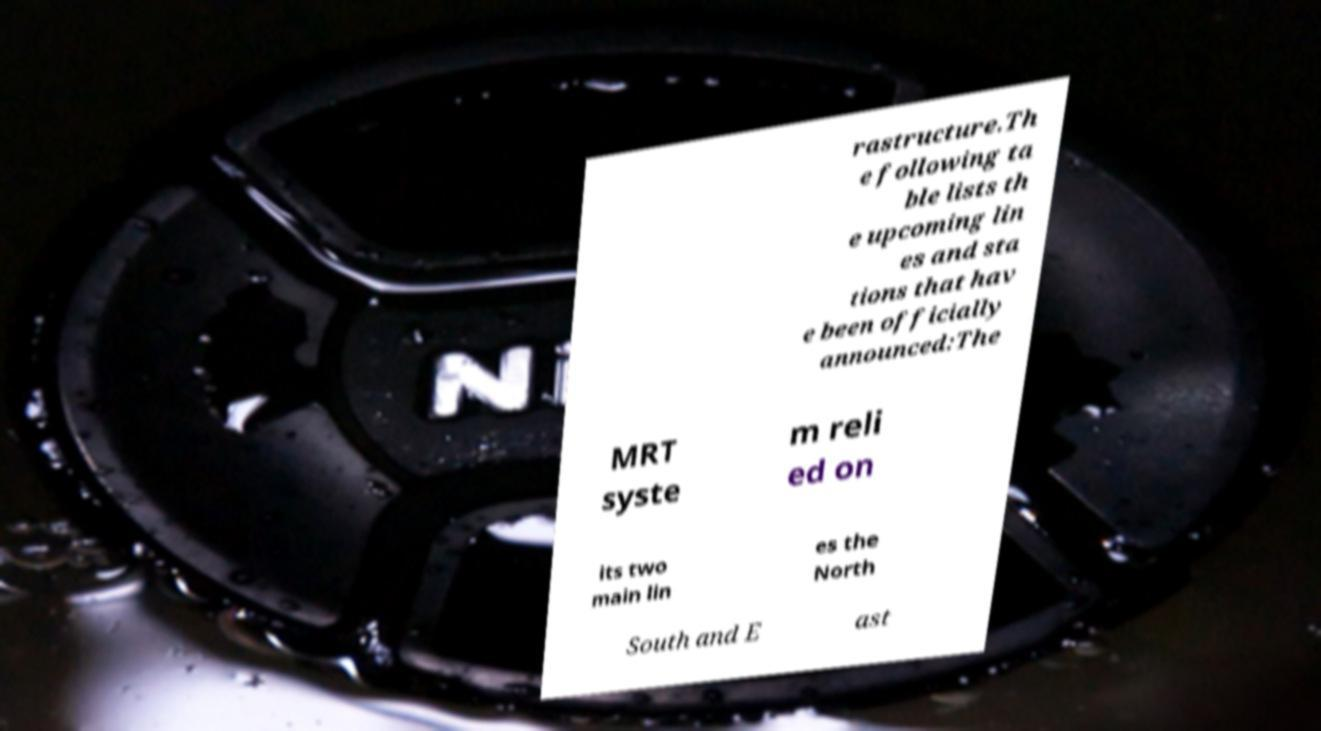Can you read and provide the text displayed in the image?This photo seems to have some interesting text. Can you extract and type it out for me? rastructure.Th e following ta ble lists th e upcoming lin es and sta tions that hav e been officially announced:The MRT syste m reli ed on its two main lin es the North South and E ast 